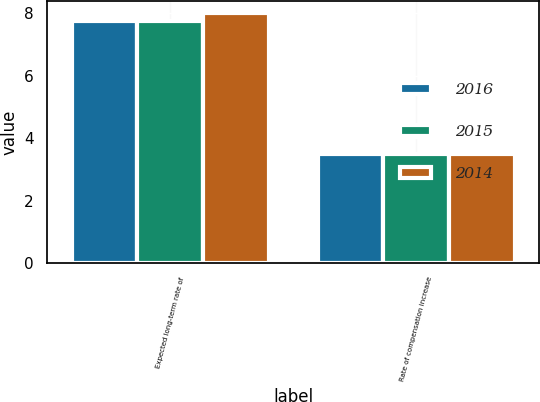<chart> <loc_0><loc_0><loc_500><loc_500><stacked_bar_chart><ecel><fcel>Expected long-term rate of<fcel>Rate of compensation increase<nl><fcel>2016<fcel>7.75<fcel>3.5<nl><fcel>2015<fcel>7.75<fcel>3.5<nl><fcel>2014<fcel>8<fcel>3.5<nl></chart> 